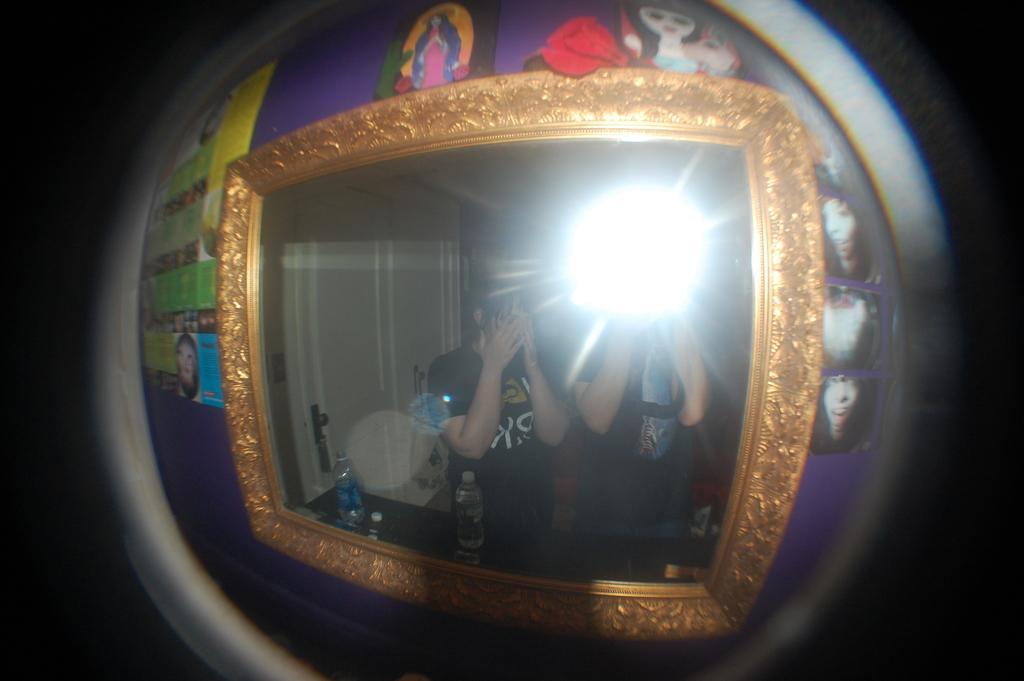Can you describe this image briefly? In the center of the image we can see one mirror. Around the mirror, we can see a few images. And we can see the border of the mirror is in a golden color. On the mirror, we can see the reflection of the two persons, light and a few other objects. 